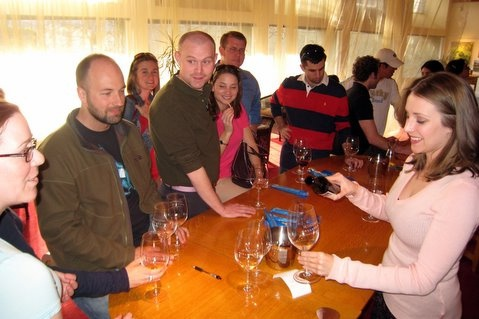Describe the objects in this image and their specific colors. I can see dining table in lightyellow, red, brown, and maroon tones, people in lightyellow, lightpink, pink, maroon, and black tones, people in lightyellow, maroon, black, and gray tones, people in lightyellow, maroon, black, salmon, and brown tones, and people in lightyellow, white, lightpink, tan, and brown tones in this image. 